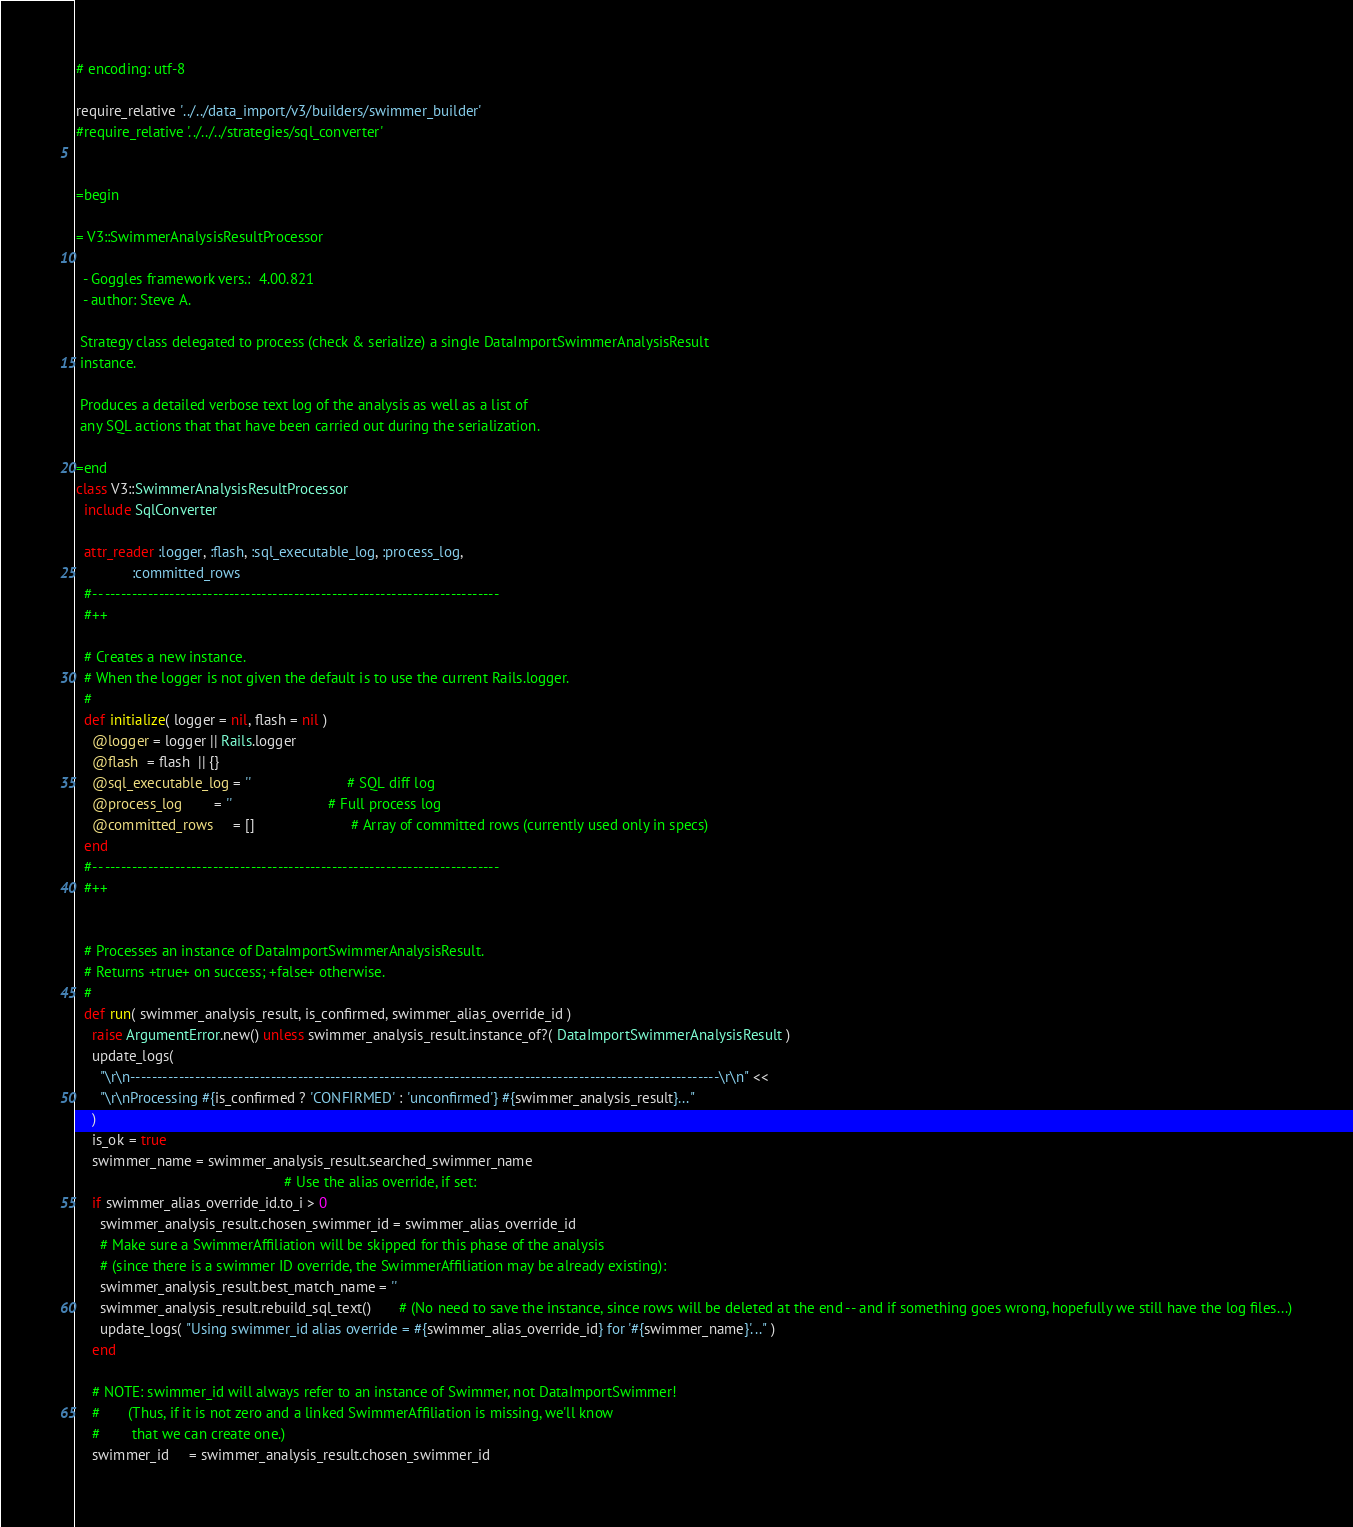<code> <loc_0><loc_0><loc_500><loc_500><_Ruby_># encoding: utf-8

require_relative '../../data_import/v3/builders/swimmer_builder'
#require_relative '../../../strategies/sql_converter'


=begin

= V3::SwimmerAnalysisResultProcessor

  - Goggles framework vers.:  4.00.821
  - author: Steve A.

 Strategy class delegated to process (check & serialize) a single DataImportSwimmerAnalysisResult
 instance.

 Produces a detailed verbose text log of the analysis as well as a list of
 any SQL actions that that have been carried out during the serialization.

=end
class V3::SwimmerAnalysisResultProcessor
  include SqlConverter

  attr_reader :logger, :flash, :sql_executable_log, :process_log,
              :committed_rows
  #-- -------------------------------------------------------------------------
  #++

  # Creates a new instance.
  # When the logger is not given the default is to use the current Rails.logger.
  #
  def initialize( logger = nil, flash = nil )
    @logger = logger || Rails.logger
    @flash  = flash  || {}
    @sql_executable_log = ''                        # SQL diff log
    @process_log        = ''                        # Full process log
    @committed_rows     = []                        # Array of committed rows (currently used only in specs)
  end
  #-- -------------------------------------------------------------------------
  #++


  # Processes an instance of DataImportSwimmerAnalysisResult.
  # Returns +true+ on success; +false+ otherwise.
  #
  def run( swimmer_analysis_result, is_confirmed, swimmer_alias_override_id )
    raise ArgumentError.new() unless swimmer_analysis_result.instance_of?( DataImportSwimmerAnalysisResult )
    update_logs(
      "\r\n-------------------------------------------------------------------------------------------------------------\r\n" <<
      "\r\nProcessing #{is_confirmed ? 'CONFIRMED' : 'unconfirmed'} #{swimmer_analysis_result}..."
    )
    is_ok = true
    swimmer_name = swimmer_analysis_result.searched_swimmer_name
                                                    # Use the alias override, if set:
    if swimmer_alias_override_id.to_i > 0
      swimmer_analysis_result.chosen_swimmer_id = swimmer_alias_override_id
      # Make sure a SwimmerAffiliation will be skipped for this phase of the analysis
      # (since there is a swimmer ID override, the SwimmerAffiliation may be already existing):
      swimmer_analysis_result.best_match_name = ''
      swimmer_analysis_result.rebuild_sql_text()       # (No need to save the instance, since rows will be deleted at the end -- and if something goes wrong, hopefully we still have the log files...)
      update_logs( "Using swimmer_id alias override = #{swimmer_alias_override_id} for '#{swimmer_name}'..." )
    end

    # NOTE: swimmer_id will always refer to an instance of Swimmer, not DataImportSwimmer!
    #       (Thus, if it is not zero and a linked SwimmerAffiliation is missing, we'll know
    #        that we can create one.)
    swimmer_id     = swimmer_analysis_result.chosen_swimmer_id</code> 